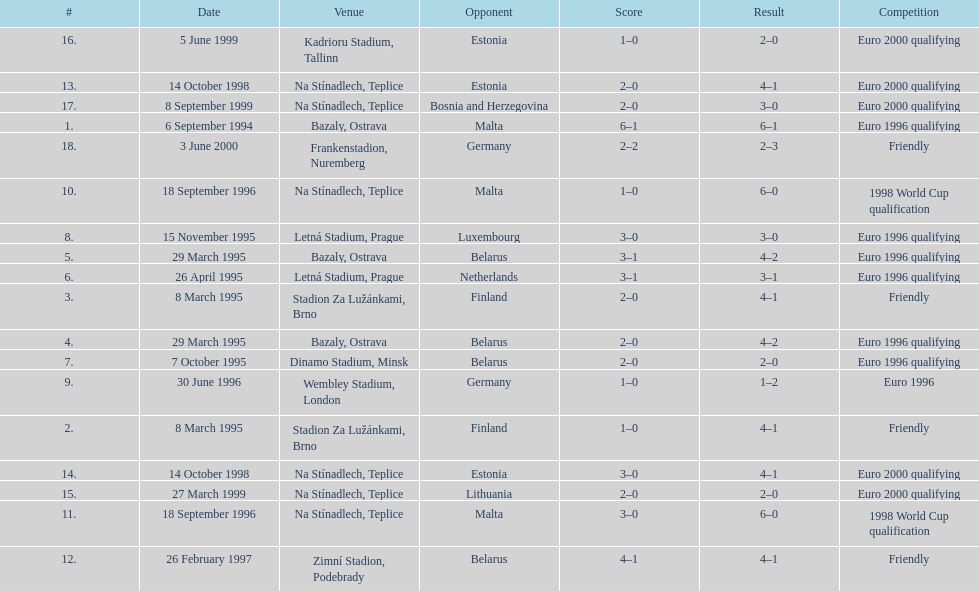Which team did czech republic score the most goals against? Malta. 